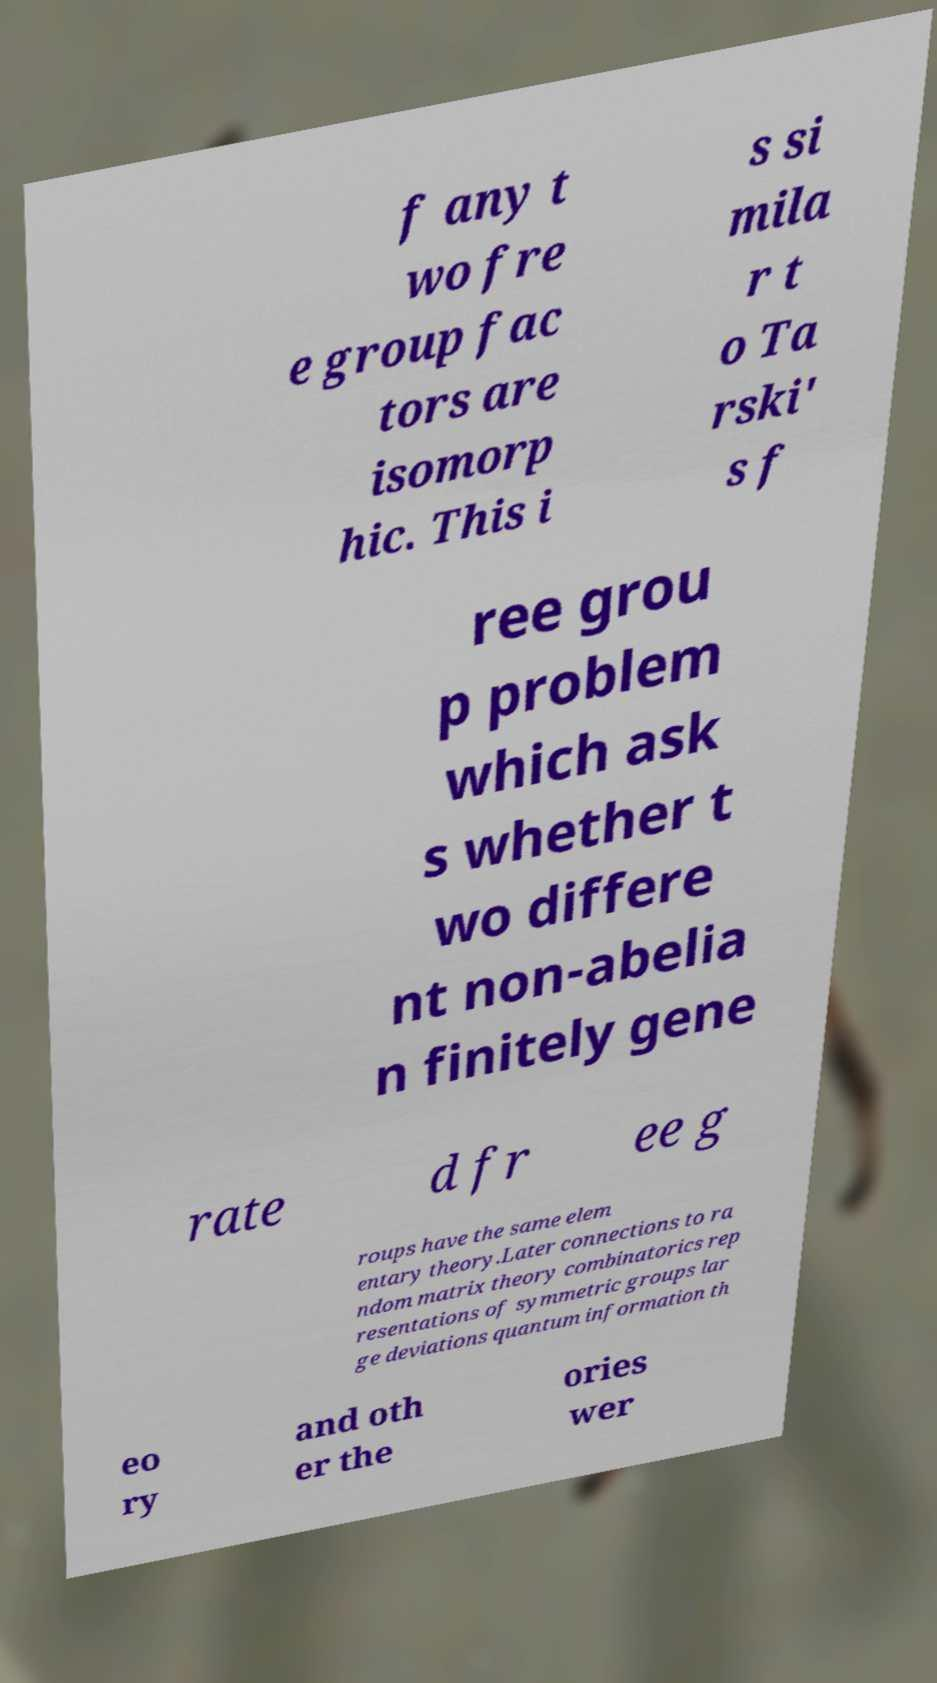Could you assist in decoding the text presented in this image and type it out clearly? f any t wo fre e group fac tors are isomorp hic. This i s si mila r t o Ta rski' s f ree grou p problem which ask s whether t wo differe nt non-abelia n finitely gene rate d fr ee g roups have the same elem entary theory.Later connections to ra ndom matrix theory combinatorics rep resentations of symmetric groups lar ge deviations quantum information th eo ry and oth er the ories wer 